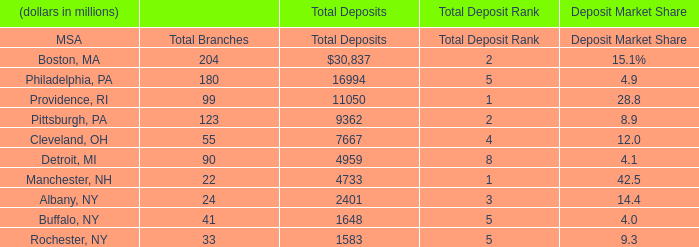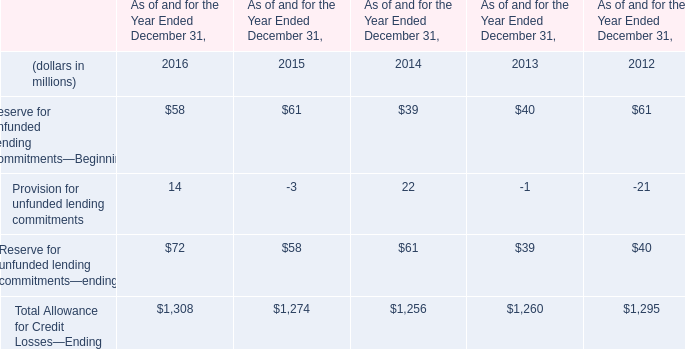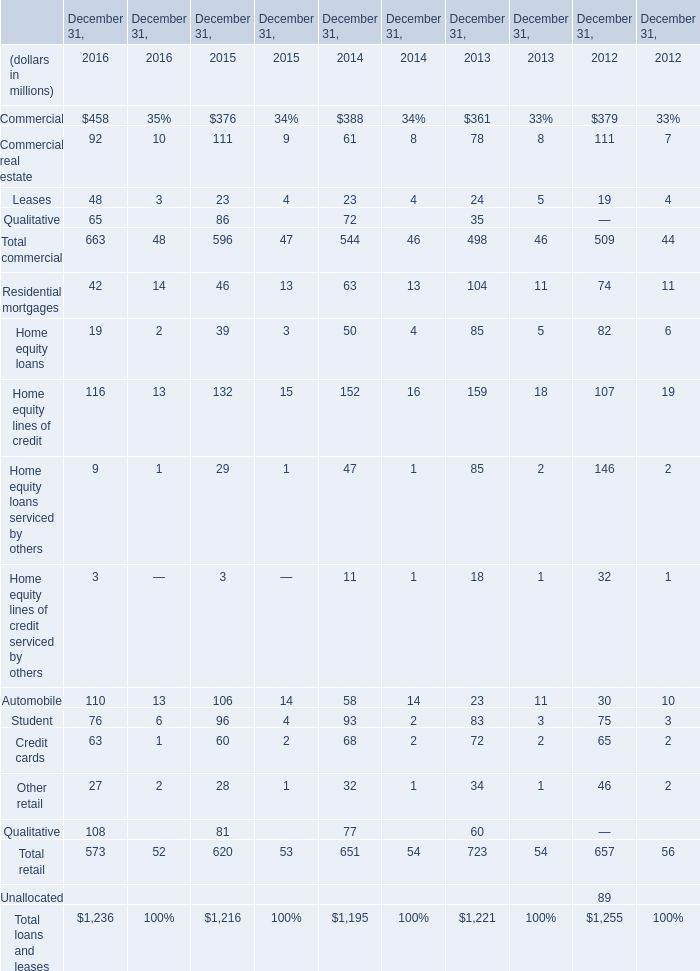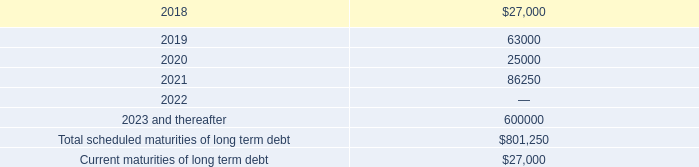What is the growing rate of Reserve for unfunded lending commitments—ending in the years with the least Reserve for Unfunded Lending Commitments—Beginning? 
Computations: ((61 - 39) / 39)
Answer: 0.5641. 